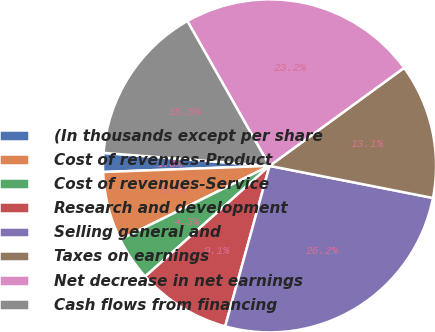Convert chart. <chart><loc_0><loc_0><loc_500><loc_500><pie_chart><fcel>(In thousands except per share<fcel>Cost of revenues-Product<fcel>Cost of revenues-Service<fcel>Research and development<fcel>Selling general and<fcel>Taxes on earnings<fcel>Net decrease in net earnings<fcel>Cash flows from financing<nl><fcel>1.83%<fcel>6.71%<fcel>4.27%<fcel>9.14%<fcel>26.2%<fcel>13.11%<fcel>23.2%<fcel>15.54%<nl></chart> 